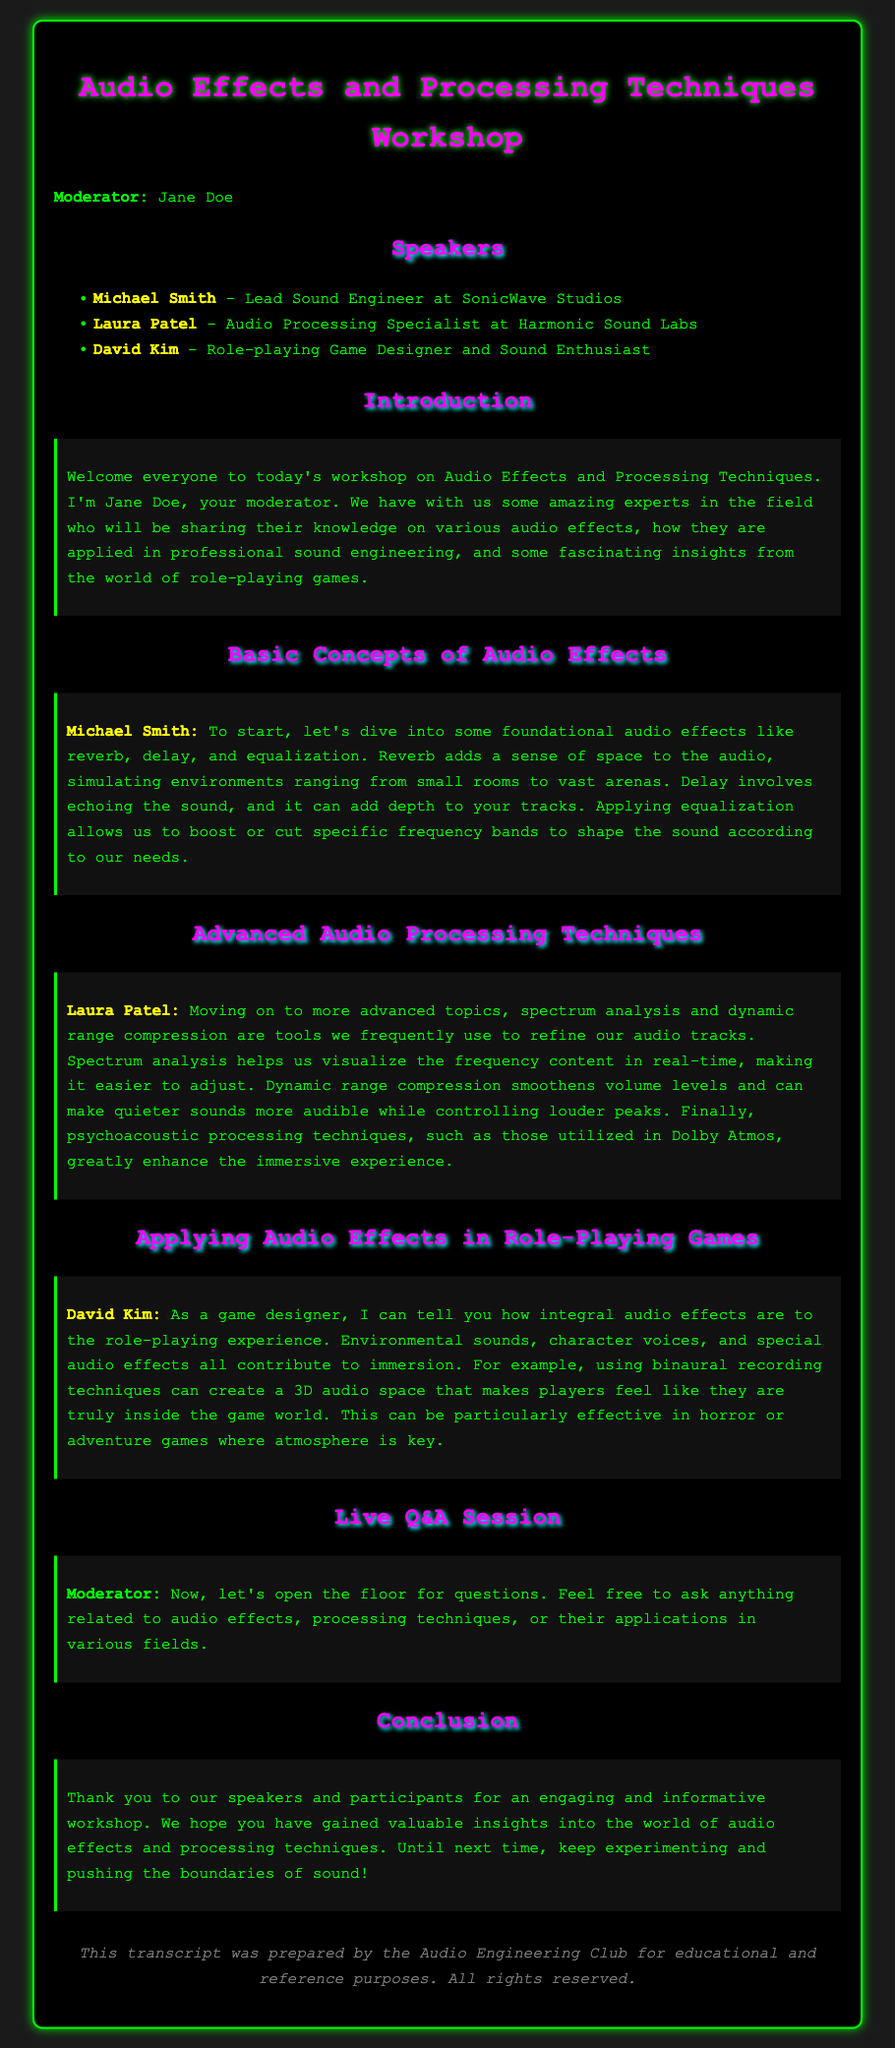What is the title of the workshop? The title is indicated prominently at the top of the document, stating what the workshop is about.
Answer: Audio Effects and Processing Techniques Workshop Who is the moderator of the workshop? The document introduces Jane Doe as the moderator who is leading the session.
Answer: Jane Doe Which company does Michael Smith represent? His affiliation is given in the speaker list, where he is identified along with his role.
Answer: SonicWave Studios What audio effect simulates environments? The document describes foundational effects, one of which is specifically aimed at creating spatial impressions.
Answer: Reverb What is one application of binaural recording techniques mentioned? David Kim discusses the immersive qualities of audio in role-playing games, particularly the effect created by this technique.
Answer: 3D audio space What type of processing technique is used to smooth volume levels? Laura Patel discusses this technique under advanced processing, highlighting its importance in refining audio.
Answer: Dynamic range compression Who contributed to the conclusion of the workshop? The conclusion outlines gratitude towards both speakers and participants, mentioning who was involved.
Answer: Speakers and participants What is the purpose of the document? The closing statement explains the intent behind creating this transcript and its intended future use.
Answer: Educational and reference purposes 